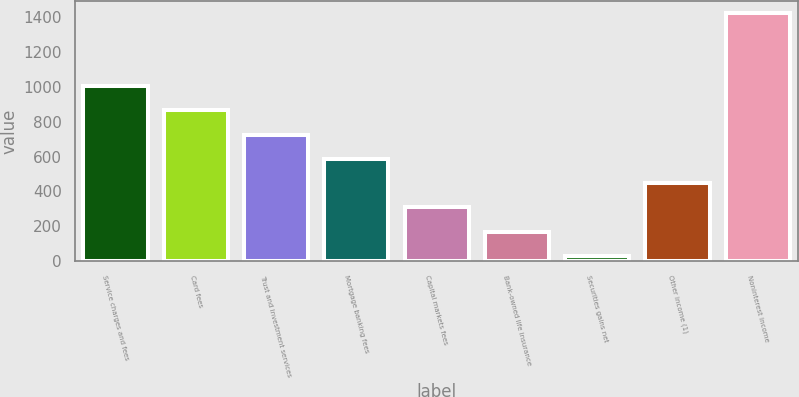<chart> <loc_0><loc_0><loc_500><loc_500><bar_chart><fcel>Service charges and fees<fcel>Card fees<fcel>Trust and investment services<fcel>Mortgage banking fees<fcel>Capital markets fees<fcel>Bank-owned life insurance<fcel>Securities gains net<fcel>Other income (1)<fcel>Noninterest income<nl><fcel>1004.1<fcel>864.8<fcel>725.5<fcel>586.2<fcel>307.6<fcel>168.3<fcel>29<fcel>446.9<fcel>1422<nl></chart> 